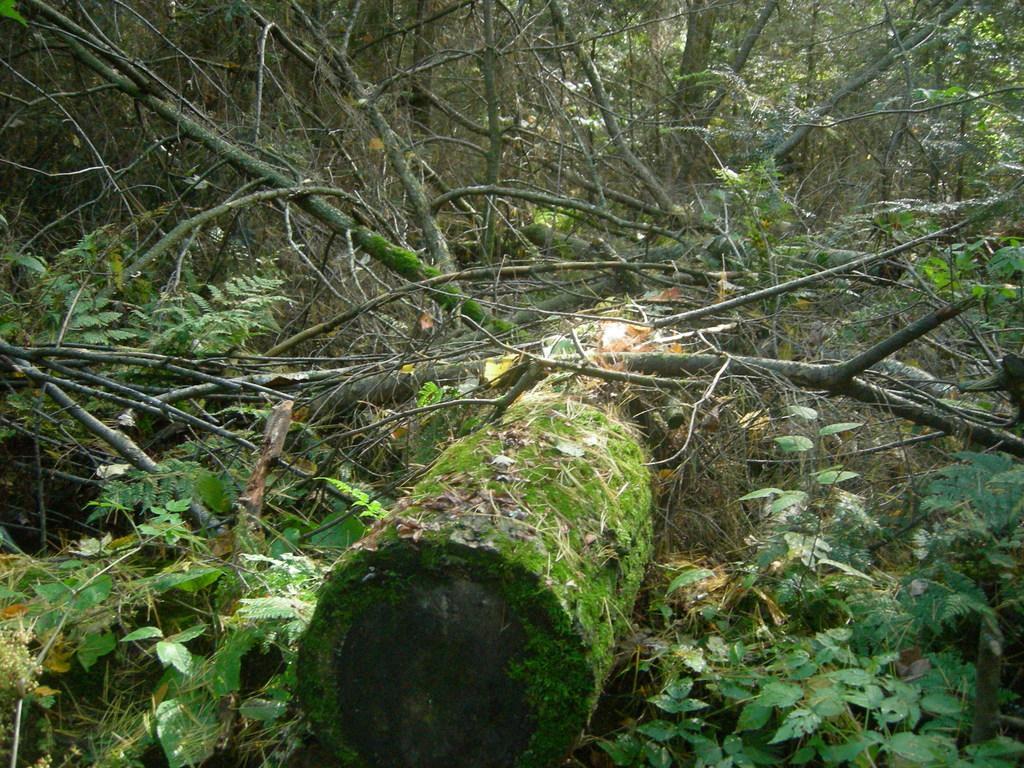Describe this image in one or two sentences. In this image I can see trees, plants and a broken tree on the ground. 